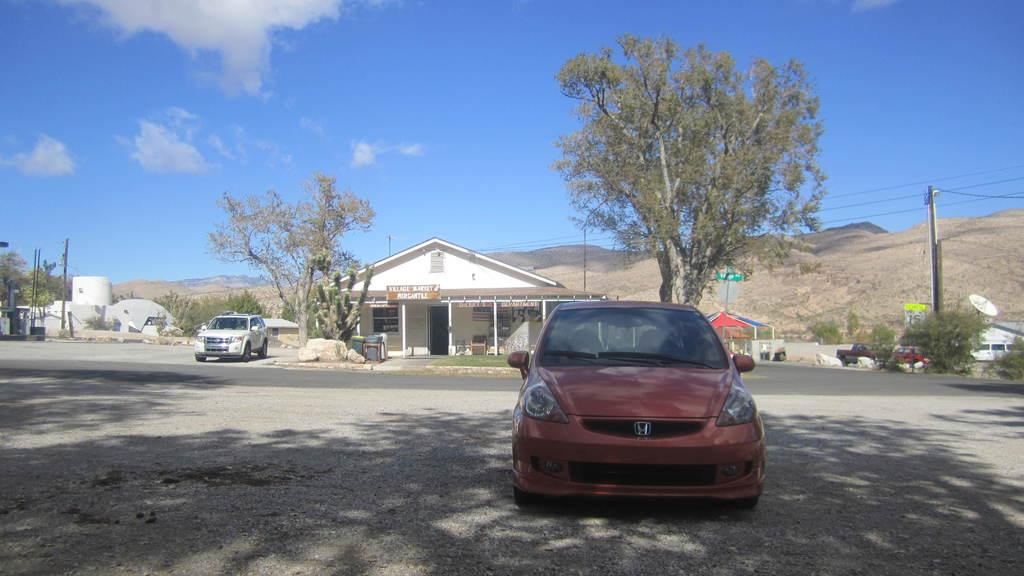What is the main subject in the middle of the image? There is a car in the middle of the image. What can be seen in the background of the image? There are trees and a house in the background of the image. What is happening on the left side of the image? A vehicle is moving on the road on the left side of the image. What is visible at the top of the image? The sky is visible at the top of the image. What type of comb is the car using to style its hair in the image? There is no comb present in the image, as cars do not have hair. 